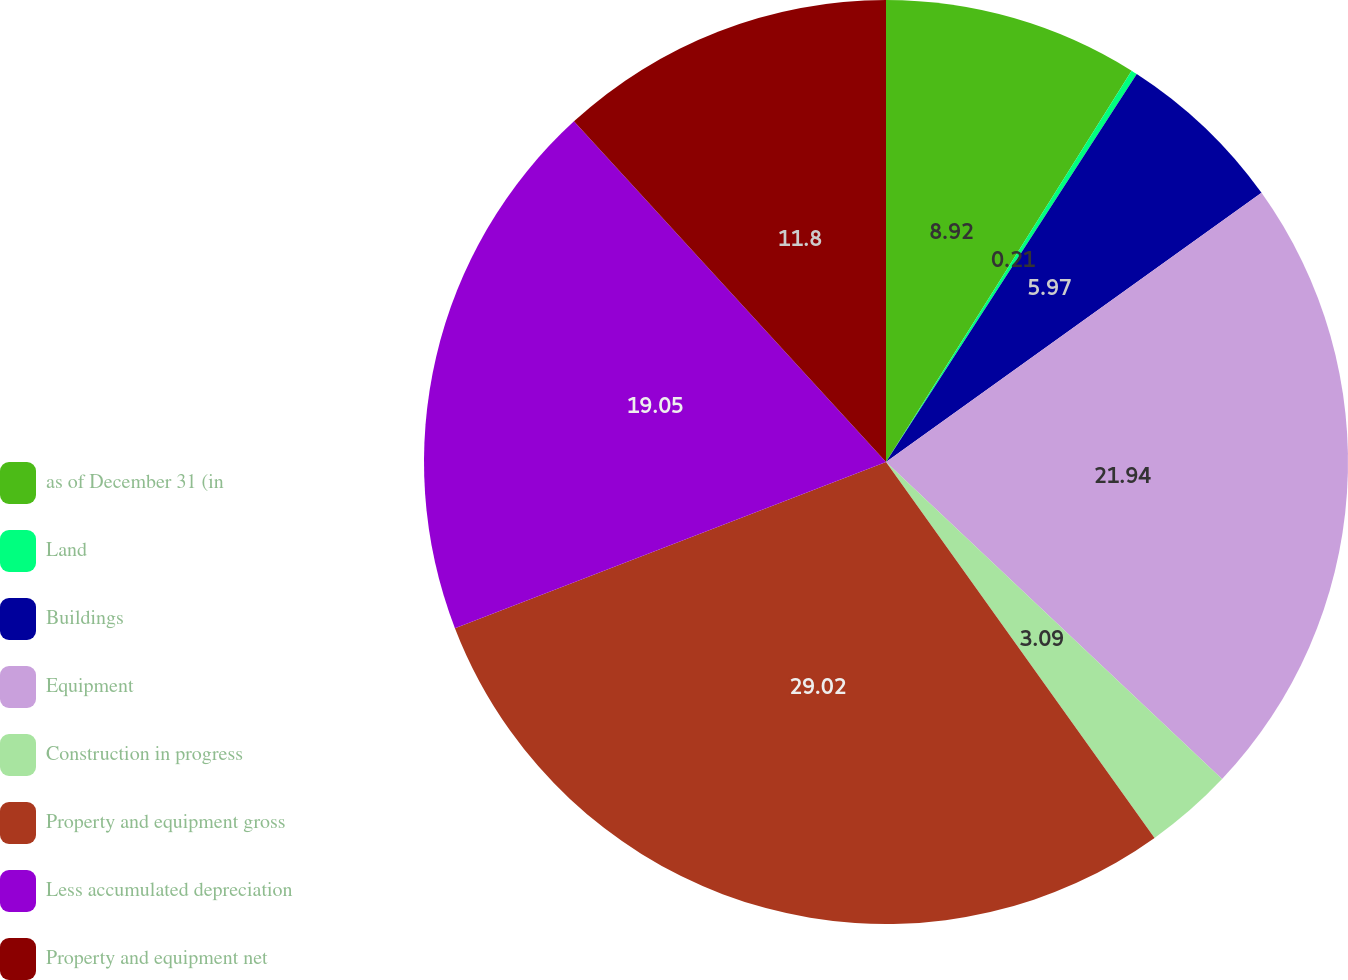Convert chart to OTSL. <chart><loc_0><loc_0><loc_500><loc_500><pie_chart><fcel>as of December 31 (in<fcel>Land<fcel>Buildings<fcel>Equipment<fcel>Construction in progress<fcel>Property and equipment gross<fcel>Less accumulated depreciation<fcel>Property and equipment net<nl><fcel>8.92%<fcel>0.21%<fcel>5.97%<fcel>21.93%<fcel>3.09%<fcel>29.01%<fcel>19.05%<fcel>11.8%<nl></chart> 